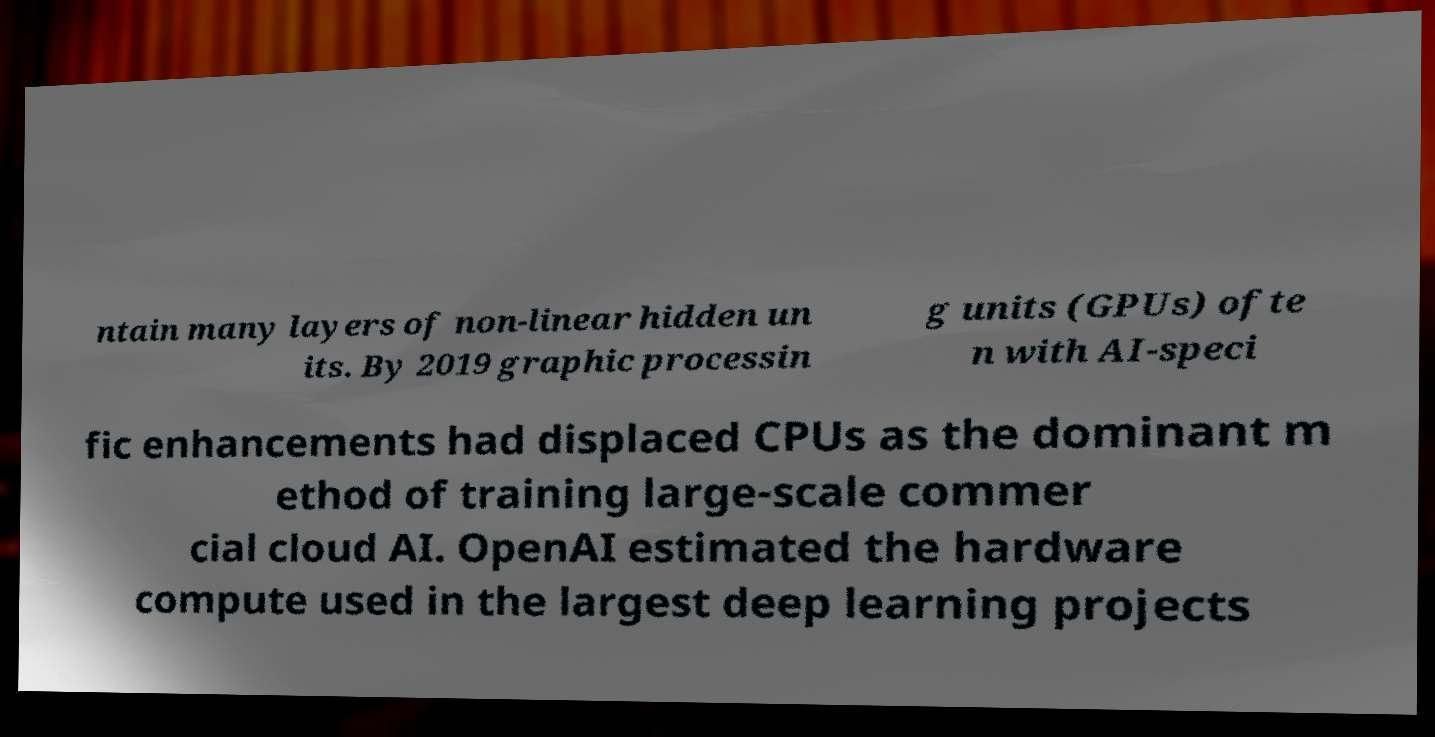There's text embedded in this image that I need extracted. Can you transcribe it verbatim? ntain many layers of non-linear hidden un its. By 2019 graphic processin g units (GPUs) ofte n with AI-speci fic enhancements had displaced CPUs as the dominant m ethod of training large-scale commer cial cloud AI. OpenAI estimated the hardware compute used in the largest deep learning projects 